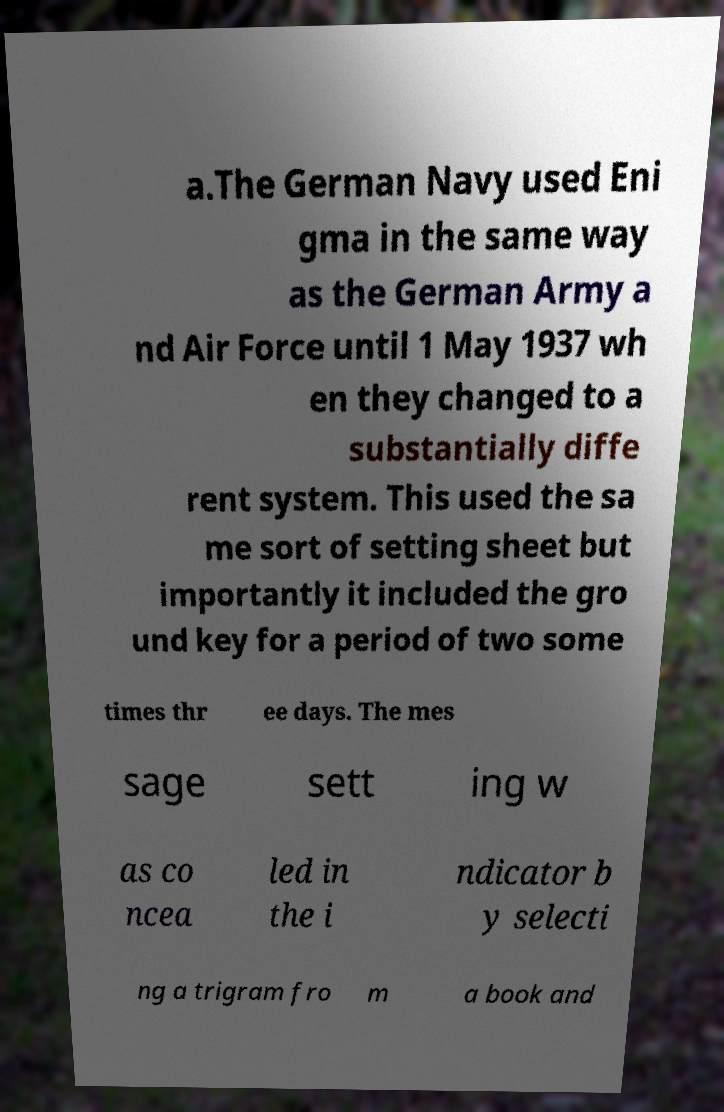There's text embedded in this image that I need extracted. Can you transcribe it verbatim? a.The German Navy used Eni gma in the same way as the German Army a nd Air Force until 1 May 1937 wh en they changed to a substantially diffe rent system. This used the sa me sort of setting sheet but importantly it included the gro und key for a period of two some times thr ee days. The mes sage sett ing w as co ncea led in the i ndicator b y selecti ng a trigram fro m a book and 